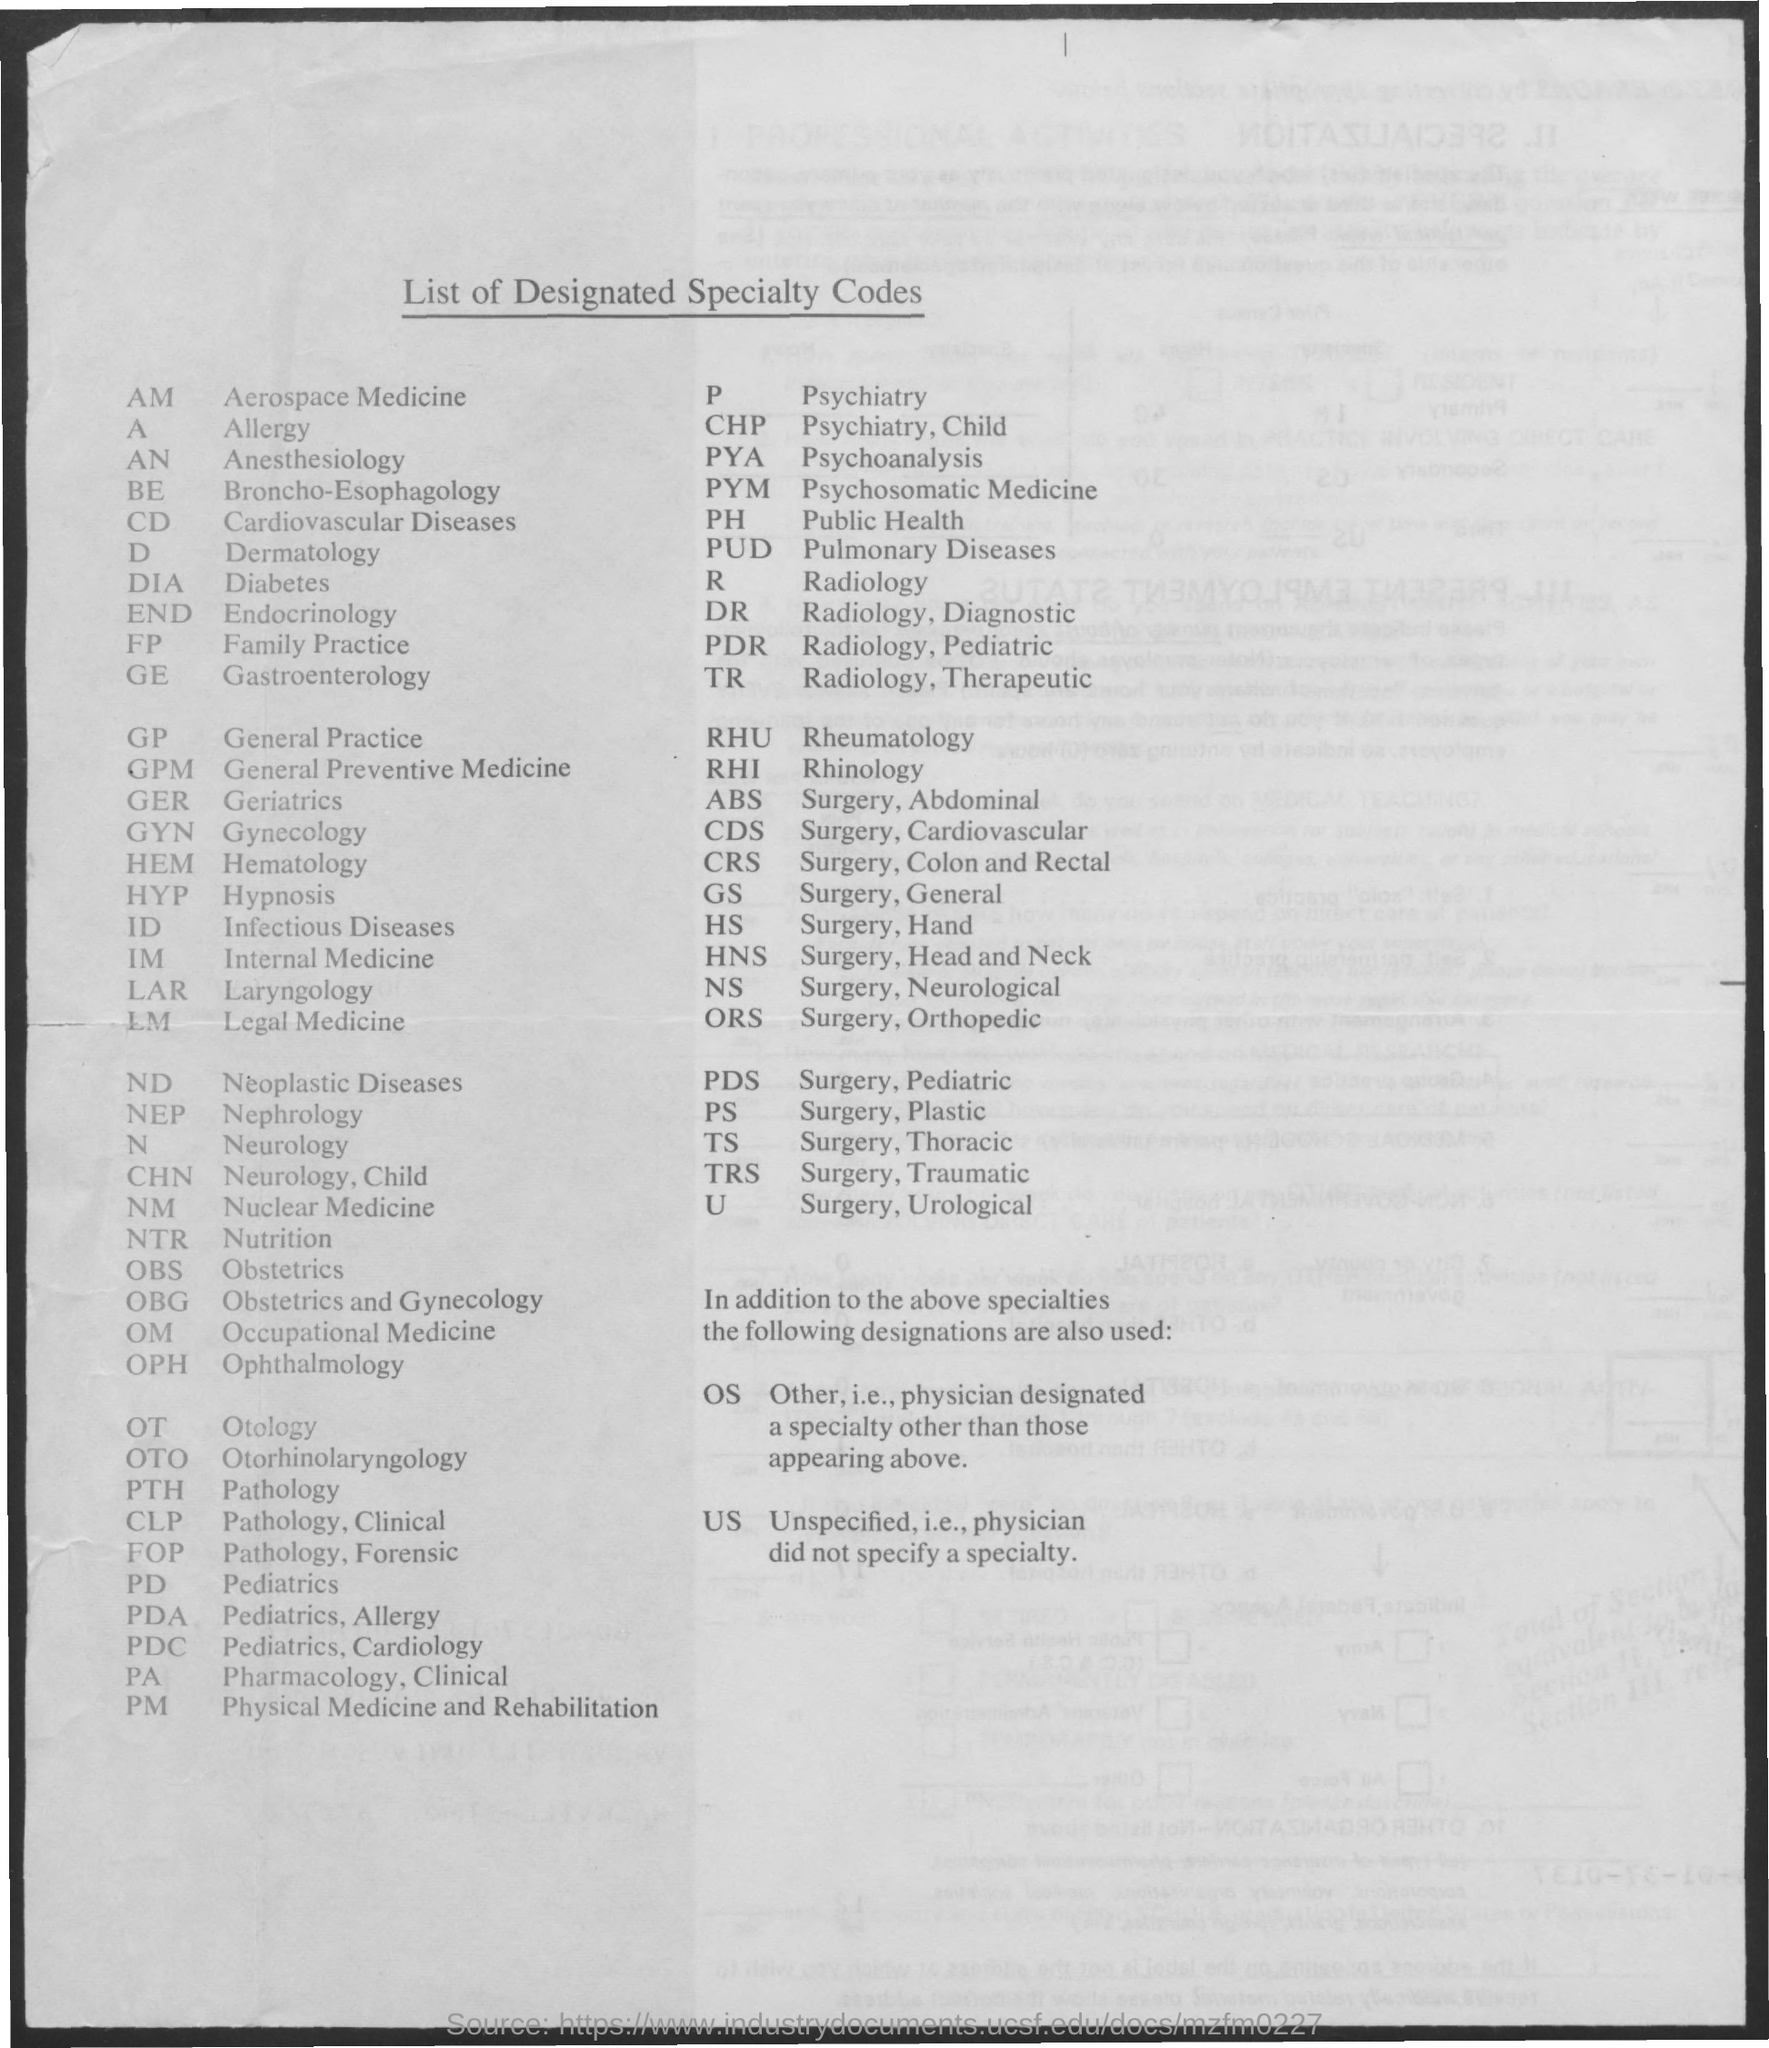What is the full form of GP?
Give a very brief answer. General Practice. What is the full form of FP?
Ensure brevity in your answer.  Family Practice. 'A' stands for?
Offer a very short reply. Allergy. The code for Otology?
Provide a short and direct response. OT. 